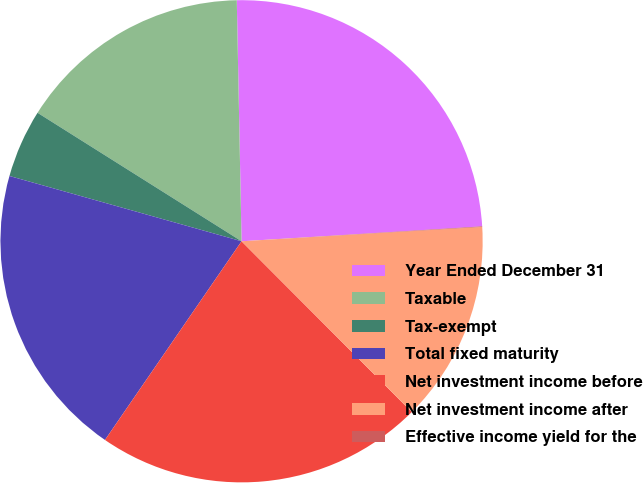Convert chart to OTSL. <chart><loc_0><loc_0><loc_500><loc_500><pie_chart><fcel>Year Ended December 31<fcel>Taxable<fcel>Tax-exempt<fcel>Total fixed maturity<fcel>Net investment income before<fcel>Net investment income after<fcel>Effective income yield for the<nl><fcel>24.33%<fcel>15.74%<fcel>4.58%<fcel>19.78%<fcel>22.06%<fcel>13.47%<fcel>0.04%<nl></chart> 